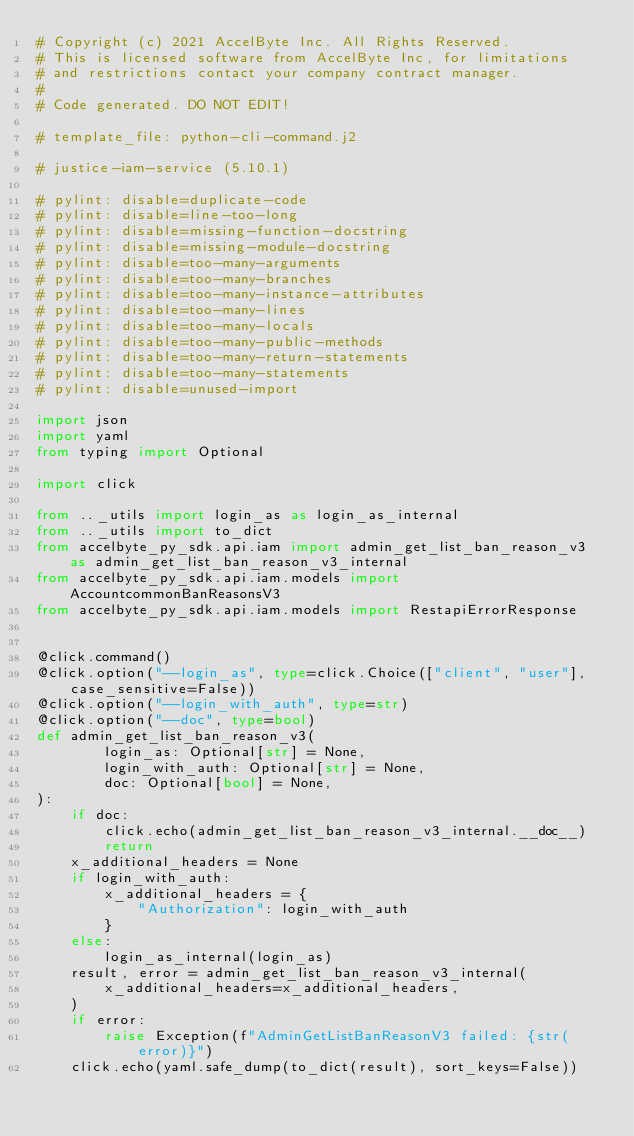<code> <loc_0><loc_0><loc_500><loc_500><_Python_># Copyright (c) 2021 AccelByte Inc. All Rights Reserved.
# This is licensed software from AccelByte Inc, for limitations
# and restrictions contact your company contract manager.
#
# Code generated. DO NOT EDIT!

# template_file: python-cli-command.j2

# justice-iam-service (5.10.1)

# pylint: disable=duplicate-code
# pylint: disable=line-too-long
# pylint: disable=missing-function-docstring
# pylint: disable=missing-module-docstring
# pylint: disable=too-many-arguments
# pylint: disable=too-many-branches
# pylint: disable=too-many-instance-attributes
# pylint: disable=too-many-lines
# pylint: disable=too-many-locals
# pylint: disable=too-many-public-methods
# pylint: disable=too-many-return-statements
# pylint: disable=too-many-statements
# pylint: disable=unused-import

import json
import yaml
from typing import Optional

import click

from .._utils import login_as as login_as_internal
from .._utils import to_dict
from accelbyte_py_sdk.api.iam import admin_get_list_ban_reason_v3 as admin_get_list_ban_reason_v3_internal
from accelbyte_py_sdk.api.iam.models import AccountcommonBanReasonsV3
from accelbyte_py_sdk.api.iam.models import RestapiErrorResponse


@click.command()
@click.option("--login_as", type=click.Choice(["client", "user"], case_sensitive=False))
@click.option("--login_with_auth", type=str)
@click.option("--doc", type=bool)
def admin_get_list_ban_reason_v3(
        login_as: Optional[str] = None,
        login_with_auth: Optional[str] = None,
        doc: Optional[bool] = None,
):
    if doc:
        click.echo(admin_get_list_ban_reason_v3_internal.__doc__)
        return
    x_additional_headers = None
    if login_with_auth:
        x_additional_headers = {
            "Authorization": login_with_auth
        }
    else:
        login_as_internal(login_as)
    result, error = admin_get_list_ban_reason_v3_internal(
        x_additional_headers=x_additional_headers,
    )
    if error:
        raise Exception(f"AdminGetListBanReasonV3 failed: {str(error)}")
    click.echo(yaml.safe_dump(to_dict(result), sort_keys=False))

</code> 